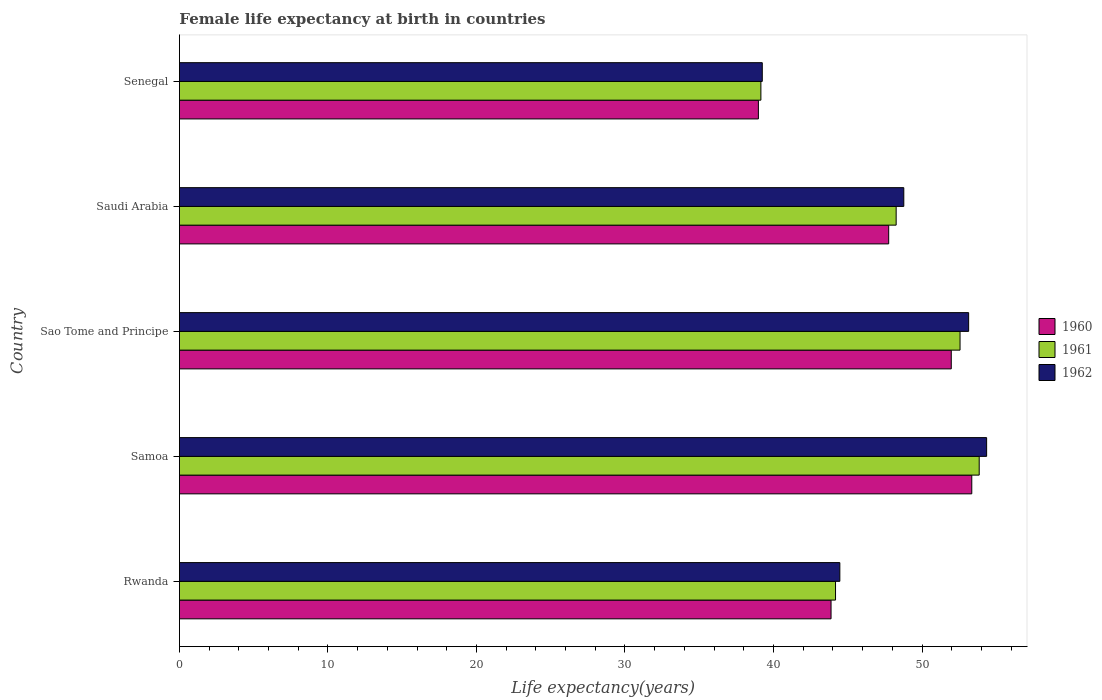How many different coloured bars are there?
Make the answer very short. 3. How many groups of bars are there?
Offer a terse response. 5. Are the number of bars per tick equal to the number of legend labels?
Make the answer very short. Yes. How many bars are there on the 1st tick from the top?
Provide a succinct answer. 3. What is the label of the 5th group of bars from the top?
Offer a terse response. Rwanda. In how many cases, is the number of bars for a given country not equal to the number of legend labels?
Keep it short and to the point. 0. What is the female life expectancy at birth in 1960 in Rwanda?
Give a very brief answer. 43.88. Across all countries, what is the maximum female life expectancy at birth in 1960?
Keep it short and to the point. 53.35. Across all countries, what is the minimum female life expectancy at birth in 1961?
Keep it short and to the point. 39.15. In which country was the female life expectancy at birth in 1960 maximum?
Offer a terse response. Samoa. In which country was the female life expectancy at birth in 1960 minimum?
Your response must be concise. Senegal. What is the total female life expectancy at birth in 1961 in the graph?
Ensure brevity in your answer.  238. What is the difference between the female life expectancy at birth in 1960 in Rwanda and that in Saudi Arabia?
Give a very brief answer. -3.88. What is the difference between the female life expectancy at birth in 1961 in Saudi Arabia and the female life expectancy at birth in 1962 in Sao Tome and Principe?
Your answer should be compact. -4.88. What is the average female life expectancy at birth in 1960 per country?
Provide a succinct answer. 47.19. What is the difference between the female life expectancy at birth in 1961 and female life expectancy at birth in 1962 in Rwanda?
Offer a very short reply. -0.29. What is the ratio of the female life expectancy at birth in 1960 in Samoa to that in Sao Tome and Principe?
Your response must be concise. 1.03. Is the female life expectancy at birth in 1961 in Sao Tome and Principe less than that in Senegal?
Provide a succinct answer. No. Is the difference between the female life expectancy at birth in 1961 in Rwanda and Samoa greater than the difference between the female life expectancy at birth in 1962 in Rwanda and Samoa?
Give a very brief answer. Yes. What is the difference between the highest and the second highest female life expectancy at birth in 1962?
Offer a very short reply. 1.21. What is the difference between the highest and the lowest female life expectancy at birth in 1961?
Keep it short and to the point. 14.7. In how many countries, is the female life expectancy at birth in 1960 greater than the average female life expectancy at birth in 1960 taken over all countries?
Provide a succinct answer. 3. What does the 1st bar from the bottom in Senegal represents?
Your answer should be compact. 1960. How many bars are there?
Offer a terse response. 15. How many countries are there in the graph?
Ensure brevity in your answer.  5. How many legend labels are there?
Your answer should be compact. 3. How are the legend labels stacked?
Keep it short and to the point. Vertical. What is the title of the graph?
Give a very brief answer. Female life expectancy at birth in countries. Does "1995" appear as one of the legend labels in the graph?
Give a very brief answer. No. What is the label or title of the X-axis?
Provide a short and direct response. Life expectancy(years). What is the label or title of the Y-axis?
Ensure brevity in your answer.  Country. What is the Life expectancy(years) in 1960 in Rwanda?
Ensure brevity in your answer.  43.88. What is the Life expectancy(years) in 1961 in Rwanda?
Offer a terse response. 44.18. What is the Life expectancy(years) in 1962 in Rwanda?
Make the answer very short. 44.47. What is the Life expectancy(years) in 1960 in Samoa?
Your answer should be compact. 53.35. What is the Life expectancy(years) in 1961 in Samoa?
Make the answer very short. 53.85. What is the Life expectancy(years) in 1962 in Samoa?
Provide a short and direct response. 54.35. What is the Life expectancy(years) in 1960 in Sao Tome and Principe?
Make the answer very short. 51.97. What is the Life expectancy(years) in 1961 in Sao Tome and Principe?
Offer a very short reply. 52.56. What is the Life expectancy(years) of 1962 in Sao Tome and Principe?
Make the answer very short. 53.14. What is the Life expectancy(years) in 1960 in Saudi Arabia?
Your response must be concise. 47.76. What is the Life expectancy(years) in 1961 in Saudi Arabia?
Offer a terse response. 48.26. What is the Life expectancy(years) of 1962 in Saudi Arabia?
Offer a very short reply. 48.77. What is the Life expectancy(years) in 1960 in Senegal?
Provide a short and direct response. 38.98. What is the Life expectancy(years) of 1961 in Senegal?
Provide a short and direct response. 39.15. What is the Life expectancy(years) of 1962 in Senegal?
Provide a succinct answer. 39.24. Across all countries, what is the maximum Life expectancy(years) in 1960?
Your response must be concise. 53.35. Across all countries, what is the maximum Life expectancy(years) in 1961?
Keep it short and to the point. 53.85. Across all countries, what is the maximum Life expectancy(years) in 1962?
Your response must be concise. 54.35. Across all countries, what is the minimum Life expectancy(years) in 1960?
Offer a terse response. 38.98. Across all countries, what is the minimum Life expectancy(years) in 1961?
Provide a succinct answer. 39.15. Across all countries, what is the minimum Life expectancy(years) in 1962?
Provide a short and direct response. 39.24. What is the total Life expectancy(years) of 1960 in the graph?
Your answer should be very brief. 235.93. What is the total Life expectancy(years) of 1961 in the graph?
Offer a very short reply. 238. What is the total Life expectancy(years) in 1962 in the graph?
Your answer should be compact. 239.97. What is the difference between the Life expectancy(years) of 1960 in Rwanda and that in Samoa?
Provide a succinct answer. -9.47. What is the difference between the Life expectancy(years) of 1961 in Rwanda and that in Samoa?
Your answer should be very brief. -9.67. What is the difference between the Life expectancy(years) of 1962 in Rwanda and that in Samoa?
Offer a very short reply. -9.88. What is the difference between the Life expectancy(years) of 1960 in Rwanda and that in Sao Tome and Principe?
Give a very brief answer. -8.09. What is the difference between the Life expectancy(years) in 1961 in Rwanda and that in Sao Tome and Principe?
Provide a short and direct response. -8.38. What is the difference between the Life expectancy(years) in 1962 in Rwanda and that in Sao Tome and Principe?
Ensure brevity in your answer.  -8.67. What is the difference between the Life expectancy(years) in 1960 in Rwanda and that in Saudi Arabia?
Offer a terse response. -3.88. What is the difference between the Life expectancy(years) of 1961 in Rwanda and that in Saudi Arabia?
Keep it short and to the point. -4.08. What is the difference between the Life expectancy(years) of 1962 in Rwanda and that in Saudi Arabia?
Provide a short and direct response. -4.31. What is the difference between the Life expectancy(years) in 1960 in Rwanda and that in Senegal?
Your answer should be very brief. 4.89. What is the difference between the Life expectancy(years) of 1961 in Rwanda and that in Senegal?
Offer a very short reply. 5.03. What is the difference between the Life expectancy(years) in 1962 in Rwanda and that in Senegal?
Your answer should be compact. 5.22. What is the difference between the Life expectancy(years) in 1960 in Samoa and that in Sao Tome and Principe?
Offer a very short reply. 1.38. What is the difference between the Life expectancy(years) of 1961 in Samoa and that in Sao Tome and Principe?
Offer a terse response. 1.29. What is the difference between the Life expectancy(years) in 1962 in Samoa and that in Sao Tome and Principe?
Your answer should be very brief. 1.21. What is the difference between the Life expectancy(years) of 1960 in Samoa and that in Saudi Arabia?
Your response must be concise. 5.59. What is the difference between the Life expectancy(years) in 1961 in Samoa and that in Saudi Arabia?
Offer a terse response. 5.59. What is the difference between the Life expectancy(years) in 1962 in Samoa and that in Saudi Arabia?
Provide a succinct answer. 5.58. What is the difference between the Life expectancy(years) in 1960 in Samoa and that in Senegal?
Offer a very short reply. 14.37. What is the difference between the Life expectancy(years) in 1961 in Samoa and that in Senegal?
Your answer should be very brief. 14.7. What is the difference between the Life expectancy(years) of 1962 in Samoa and that in Senegal?
Your response must be concise. 15.11. What is the difference between the Life expectancy(years) in 1960 in Sao Tome and Principe and that in Saudi Arabia?
Provide a short and direct response. 4.21. What is the difference between the Life expectancy(years) of 1961 in Sao Tome and Principe and that in Saudi Arabia?
Give a very brief answer. 4.3. What is the difference between the Life expectancy(years) of 1962 in Sao Tome and Principe and that in Saudi Arabia?
Your response must be concise. 4.37. What is the difference between the Life expectancy(years) of 1960 in Sao Tome and Principe and that in Senegal?
Give a very brief answer. 12.99. What is the difference between the Life expectancy(years) in 1961 in Sao Tome and Principe and that in Senegal?
Offer a terse response. 13.41. What is the difference between the Life expectancy(years) in 1962 in Sao Tome and Principe and that in Senegal?
Provide a succinct answer. 13.89. What is the difference between the Life expectancy(years) of 1960 in Saudi Arabia and that in Senegal?
Offer a very short reply. 8.77. What is the difference between the Life expectancy(years) of 1961 in Saudi Arabia and that in Senegal?
Ensure brevity in your answer.  9.11. What is the difference between the Life expectancy(years) of 1962 in Saudi Arabia and that in Senegal?
Your answer should be very brief. 9.53. What is the difference between the Life expectancy(years) of 1960 in Rwanda and the Life expectancy(years) of 1961 in Samoa?
Your response must be concise. -9.97. What is the difference between the Life expectancy(years) in 1960 in Rwanda and the Life expectancy(years) in 1962 in Samoa?
Ensure brevity in your answer.  -10.47. What is the difference between the Life expectancy(years) of 1961 in Rwanda and the Life expectancy(years) of 1962 in Samoa?
Ensure brevity in your answer.  -10.17. What is the difference between the Life expectancy(years) of 1960 in Rwanda and the Life expectancy(years) of 1961 in Sao Tome and Principe?
Give a very brief answer. -8.69. What is the difference between the Life expectancy(years) of 1960 in Rwanda and the Life expectancy(years) of 1962 in Sao Tome and Principe?
Keep it short and to the point. -9.26. What is the difference between the Life expectancy(years) of 1961 in Rwanda and the Life expectancy(years) of 1962 in Sao Tome and Principe?
Your answer should be compact. -8.96. What is the difference between the Life expectancy(years) of 1960 in Rwanda and the Life expectancy(years) of 1961 in Saudi Arabia?
Ensure brevity in your answer.  -4.38. What is the difference between the Life expectancy(years) of 1960 in Rwanda and the Life expectancy(years) of 1962 in Saudi Arabia?
Your response must be concise. -4.9. What is the difference between the Life expectancy(years) of 1961 in Rwanda and the Life expectancy(years) of 1962 in Saudi Arabia?
Make the answer very short. -4.6. What is the difference between the Life expectancy(years) in 1960 in Rwanda and the Life expectancy(years) in 1961 in Senegal?
Provide a succinct answer. 4.72. What is the difference between the Life expectancy(years) in 1960 in Rwanda and the Life expectancy(years) in 1962 in Senegal?
Keep it short and to the point. 4.63. What is the difference between the Life expectancy(years) of 1961 in Rwanda and the Life expectancy(years) of 1962 in Senegal?
Give a very brief answer. 4.93. What is the difference between the Life expectancy(years) of 1960 in Samoa and the Life expectancy(years) of 1961 in Sao Tome and Principe?
Ensure brevity in your answer.  0.79. What is the difference between the Life expectancy(years) of 1960 in Samoa and the Life expectancy(years) of 1962 in Sao Tome and Principe?
Make the answer very short. 0.21. What is the difference between the Life expectancy(years) of 1961 in Samoa and the Life expectancy(years) of 1962 in Sao Tome and Principe?
Your answer should be very brief. 0.71. What is the difference between the Life expectancy(years) in 1960 in Samoa and the Life expectancy(years) in 1961 in Saudi Arabia?
Ensure brevity in your answer.  5.09. What is the difference between the Life expectancy(years) in 1960 in Samoa and the Life expectancy(years) in 1962 in Saudi Arabia?
Your answer should be compact. 4.58. What is the difference between the Life expectancy(years) in 1961 in Samoa and the Life expectancy(years) in 1962 in Saudi Arabia?
Ensure brevity in your answer.  5.08. What is the difference between the Life expectancy(years) of 1960 in Samoa and the Life expectancy(years) of 1961 in Senegal?
Ensure brevity in your answer.  14.2. What is the difference between the Life expectancy(years) in 1960 in Samoa and the Life expectancy(years) in 1962 in Senegal?
Make the answer very short. 14.11. What is the difference between the Life expectancy(years) in 1961 in Samoa and the Life expectancy(years) in 1962 in Senegal?
Provide a succinct answer. 14.61. What is the difference between the Life expectancy(years) in 1960 in Sao Tome and Principe and the Life expectancy(years) in 1961 in Saudi Arabia?
Provide a succinct answer. 3.71. What is the difference between the Life expectancy(years) in 1960 in Sao Tome and Principe and the Life expectancy(years) in 1962 in Saudi Arabia?
Offer a terse response. 3.2. What is the difference between the Life expectancy(years) in 1961 in Sao Tome and Principe and the Life expectancy(years) in 1962 in Saudi Arabia?
Your answer should be compact. 3.79. What is the difference between the Life expectancy(years) in 1960 in Sao Tome and Principe and the Life expectancy(years) in 1961 in Senegal?
Your answer should be very brief. 12.82. What is the difference between the Life expectancy(years) in 1960 in Sao Tome and Principe and the Life expectancy(years) in 1962 in Senegal?
Make the answer very short. 12.72. What is the difference between the Life expectancy(years) in 1961 in Sao Tome and Principe and the Life expectancy(years) in 1962 in Senegal?
Give a very brief answer. 13.32. What is the difference between the Life expectancy(years) in 1960 in Saudi Arabia and the Life expectancy(years) in 1961 in Senegal?
Keep it short and to the point. 8.6. What is the difference between the Life expectancy(years) of 1960 in Saudi Arabia and the Life expectancy(years) of 1962 in Senegal?
Give a very brief answer. 8.51. What is the difference between the Life expectancy(years) in 1961 in Saudi Arabia and the Life expectancy(years) in 1962 in Senegal?
Provide a succinct answer. 9.01. What is the average Life expectancy(years) in 1960 per country?
Offer a very short reply. 47.19. What is the average Life expectancy(years) in 1961 per country?
Give a very brief answer. 47.6. What is the average Life expectancy(years) of 1962 per country?
Give a very brief answer. 47.99. What is the difference between the Life expectancy(years) in 1960 and Life expectancy(years) in 1961 in Rwanda?
Provide a short and direct response. -0.3. What is the difference between the Life expectancy(years) of 1960 and Life expectancy(years) of 1962 in Rwanda?
Offer a very short reply. -0.59. What is the difference between the Life expectancy(years) of 1961 and Life expectancy(years) of 1962 in Rwanda?
Keep it short and to the point. -0.29. What is the difference between the Life expectancy(years) of 1960 and Life expectancy(years) of 1961 in Samoa?
Make the answer very short. -0.5. What is the difference between the Life expectancy(years) of 1960 and Life expectancy(years) of 1962 in Samoa?
Your answer should be compact. -1. What is the difference between the Life expectancy(years) in 1961 and Life expectancy(years) in 1962 in Samoa?
Offer a terse response. -0.5. What is the difference between the Life expectancy(years) in 1960 and Life expectancy(years) in 1961 in Sao Tome and Principe?
Keep it short and to the point. -0.59. What is the difference between the Life expectancy(years) in 1960 and Life expectancy(years) in 1962 in Sao Tome and Principe?
Ensure brevity in your answer.  -1.17. What is the difference between the Life expectancy(years) of 1961 and Life expectancy(years) of 1962 in Sao Tome and Principe?
Provide a short and direct response. -0.58. What is the difference between the Life expectancy(years) in 1960 and Life expectancy(years) in 1961 in Saudi Arabia?
Provide a succinct answer. -0.5. What is the difference between the Life expectancy(years) of 1960 and Life expectancy(years) of 1962 in Saudi Arabia?
Offer a terse response. -1.02. What is the difference between the Life expectancy(years) in 1961 and Life expectancy(years) in 1962 in Saudi Arabia?
Provide a succinct answer. -0.52. What is the difference between the Life expectancy(years) of 1960 and Life expectancy(years) of 1961 in Senegal?
Your response must be concise. -0.17. What is the difference between the Life expectancy(years) in 1960 and Life expectancy(years) in 1962 in Senegal?
Provide a short and direct response. -0.26. What is the difference between the Life expectancy(years) in 1961 and Life expectancy(years) in 1962 in Senegal?
Your answer should be compact. -0.09. What is the ratio of the Life expectancy(years) in 1960 in Rwanda to that in Samoa?
Keep it short and to the point. 0.82. What is the ratio of the Life expectancy(years) in 1961 in Rwanda to that in Samoa?
Ensure brevity in your answer.  0.82. What is the ratio of the Life expectancy(years) of 1962 in Rwanda to that in Samoa?
Your response must be concise. 0.82. What is the ratio of the Life expectancy(years) of 1960 in Rwanda to that in Sao Tome and Principe?
Provide a succinct answer. 0.84. What is the ratio of the Life expectancy(years) in 1961 in Rwanda to that in Sao Tome and Principe?
Offer a terse response. 0.84. What is the ratio of the Life expectancy(years) in 1962 in Rwanda to that in Sao Tome and Principe?
Ensure brevity in your answer.  0.84. What is the ratio of the Life expectancy(years) in 1960 in Rwanda to that in Saudi Arabia?
Give a very brief answer. 0.92. What is the ratio of the Life expectancy(years) of 1961 in Rwanda to that in Saudi Arabia?
Your response must be concise. 0.92. What is the ratio of the Life expectancy(years) of 1962 in Rwanda to that in Saudi Arabia?
Your answer should be very brief. 0.91. What is the ratio of the Life expectancy(years) in 1960 in Rwanda to that in Senegal?
Your response must be concise. 1.13. What is the ratio of the Life expectancy(years) in 1961 in Rwanda to that in Senegal?
Ensure brevity in your answer.  1.13. What is the ratio of the Life expectancy(years) of 1962 in Rwanda to that in Senegal?
Make the answer very short. 1.13. What is the ratio of the Life expectancy(years) of 1960 in Samoa to that in Sao Tome and Principe?
Offer a terse response. 1.03. What is the ratio of the Life expectancy(years) in 1961 in Samoa to that in Sao Tome and Principe?
Your answer should be compact. 1.02. What is the ratio of the Life expectancy(years) of 1962 in Samoa to that in Sao Tome and Principe?
Your answer should be compact. 1.02. What is the ratio of the Life expectancy(years) in 1960 in Samoa to that in Saudi Arabia?
Your answer should be very brief. 1.12. What is the ratio of the Life expectancy(years) in 1961 in Samoa to that in Saudi Arabia?
Your answer should be very brief. 1.12. What is the ratio of the Life expectancy(years) in 1962 in Samoa to that in Saudi Arabia?
Ensure brevity in your answer.  1.11. What is the ratio of the Life expectancy(years) in 1960 in Samoa to that in Senegal?
Make the answer very short. 1.37. What is the ratio of the Life expectancy(years) of 1961 in Samoa to that in Senegal?
Give a very brief answer. 1.38. What is the ratio of the Life expectancy(years) in 1962 in Samoa to that in Senegal?
Make the answer very short. 1.38. What is the ratio of the Life expectancy(years) in 1960 in Sao Tome and Principe to that in Saudi Arabia?
Your answer should be compact. 1.09. What is the ratio of the Life expectancy(years) of 1961 in Sao Tome and Principe to that in Saudi Arabia?
Offer a terse response. 1.09. What is the ratio of the Life expectancy(years) of 1962 in Sao Tome and Principe to that in Saudi Arabia?
Provide a succinct answer. 1.09. What is the ratio of the Life expectancy(years) of 1960 in Sao Tome and Principe to that in Senegal?
Keep it short and to the point. 1.33. What is the ratio of the Life expectancy(years) of 1961 in Sao Tome and Principe to that in Senegal?
Provide a succinct answer. 1.34. What is the ratio of the Life expectancy(years) of 1962 in Sao Tome and Principe to that in Senegal?
Make the answer very short. 1.35. What is the ratio of the Life expectancy(years) of 1960 in Saudi Arabia to that in Senegal?
Keep it short and to the point. 1.23. What is the ratio of the Life expectancy(years) in 1961 in Saudi Arabia to that in Senegal?
Your answer should be compact. 1.23. What is the ratio of the Life expectancy(years) in 1962 in Saudi Arabia to that in Senegal?
Provide a short and direct response. 1.24. What is the difference between the highest and the second highest Life expectancy(years) of 1960?
Your response must be concise. 1.38. What is the difference between the highest and the second highest Life expectancy(years) of 1961?
Offer a terse response. 1.29. What is the difference between the highest and the second highest Life expectancy(years) in 1962?
Provide a short and direct response. 1.21. What is the difference between the highest and the lowest Life expectancy(years) of 1960?
Your answer should be very brief. 14.37. What is the difference between the highest and the lowest Life expectancy(years) in 1961?
Provide a succinct answer. 14.7. What is the difference between the highest and the lowest Life expectancy(years) in 1962?
Provide a succinct answer. 15.11. 